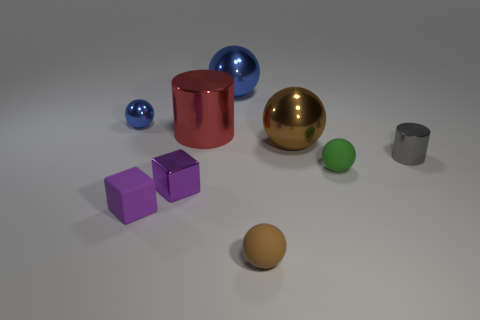Are there more red cylinders that are in front of the big red metallic cylinder than green spheres?
Offer a terse response. No. What number of gray rubber cylinders have the same size as the purple metallic block?
Your answer should be compact. 0. What size is the other cube that is the same color as the rubber cube?
Your answer should be compact. Small. What number of objects are either tiny purple metallic objects or large things that are in front of the big blue shiny sphere?
Offer a terse response. 3. What is the color of the metal thing that is right of the tiny blue shiny object and behind the large red object?
Give a very brief answer. Blue. Does the red metallic cylinder have the same size as the gray shiny thing?
Make the answer very short. No. There is a tiny ball that is to the left of the big red shiny thing; what is its color?
Provide a succinct answer. Blue. Are there any other cylinders of the same color as the large metal cylinder?
Give a very brief answer. No. There is a sphere that is the same size as the brown metallic object; what color is it?
Give a very brief answer. Blue. Does the gray thing have the same shape as the purple metal thing?
Keep it short and to the point. No. 